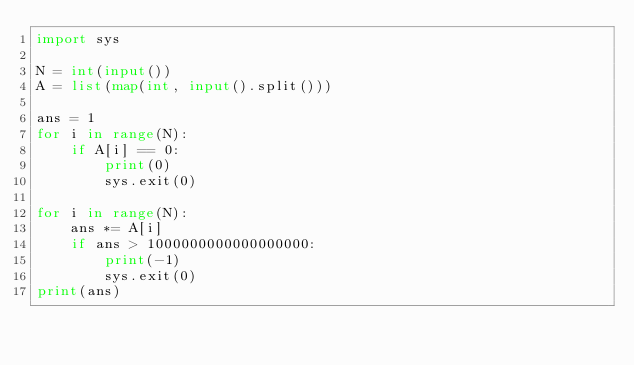<code> <loc_0><loc_0><loc_500><loc_500><_Python_>import sys

N = int(input())
A = list(map(int, input().split()))

ans = 1
for i in range(N):
    if A[i] == 0:
        print(0)
        sys.exit(0)

for i in range(N):
    ans *= A[i]
    if ans > 1000000000000000000:
        print(-1)
        sys.exit(0)
print(ans)
</code> 